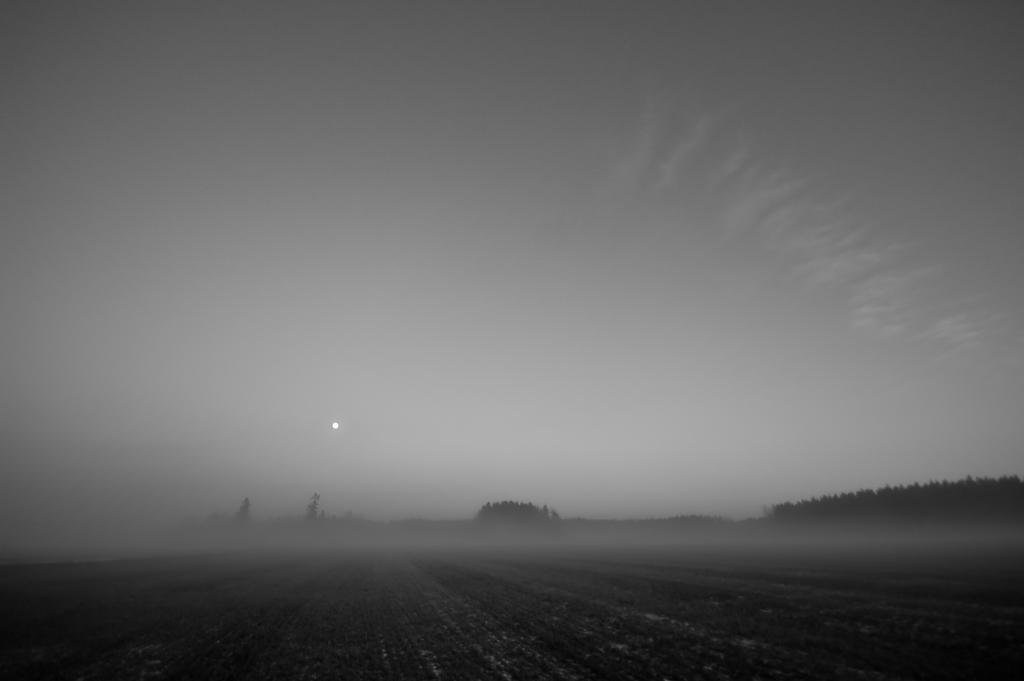What type of vegetation can be seen in the image? There are trees in the middle to right side of the image. What structure is partially visible in the image? There is a roof visible in the image. What part of the natural environment is visible in the image? The sky is visible in the image. What type of legal advice can be obtained from the trees in the image? There are no lawyers or legal advice present in the image; it features trees, a roof, and the sky. What arithmetic problem can be solved using the stream in the image? There is no stream present in the image, so no arithmetic problem can be solved using it. 